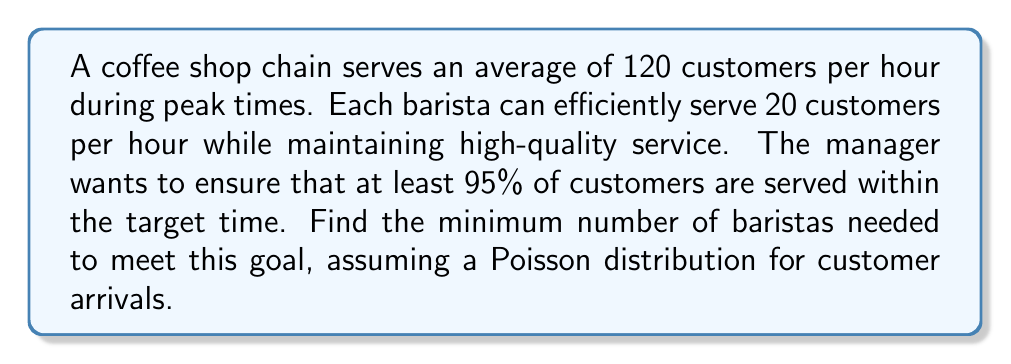Can you answer this question? To solve this problem, we'll use the following steps:

1) First, we need to calculate the average number of customers served per hour (λ):
   λ = 120 customers/hour

2) We want to find the minimum number of baristas (n) such that the probability of serving 120 or fewer customers is at least 0.95.

3) Using the Poisson distribution, we can express this as:

   $$P(X \leq 120) \geq 0.95$$

   Where X is the number of customers that can be served in an hour.

4) The capacity of service (μ) with n baristas is:
   
   $$\mu = 20n$$

5) We can use the cumulative distribution function of the Poisson distribution:

   $$P(X \leq 120) = e^{-\mu} \sum_{k=0}^{120} \frac{\mu^k}{k!} \geq 0.95$$

6) We need to find the smallest n that satisfies this inequality. We can use trial and error or a computer program to solve this.

7) After calculation, we find that when n = 7:
   
   $$P(X \leq 120) \approx 0.9505 > 0.95$$

8) When n = 6:
   
   $$P(X \leq 120) \approx 0.8968 < 0.95$$

Therefore, the minimum number of baristas needed is 7.
Answer: 7 baristas 